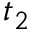Convert formula to latex. <formula><loc_0><loc_0><loc_500><loc_500>t _ { 2 }</formula> 